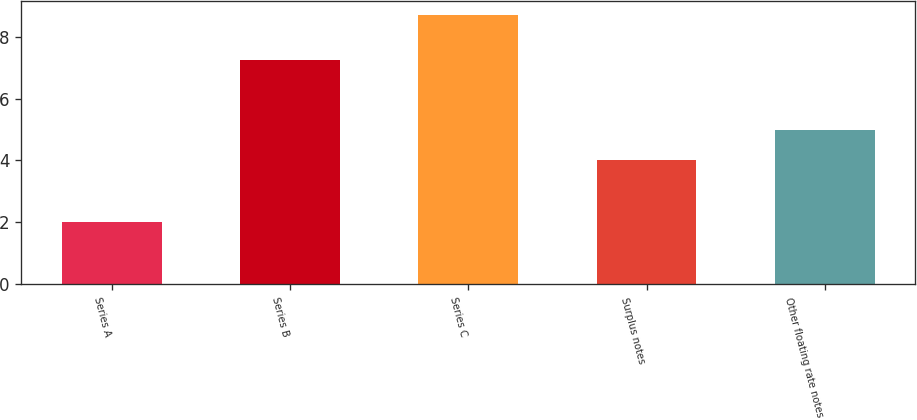<chart> <loc_0><loc_0><loc_500><loc_500><bar_chart><fcel>Series A<fcel>Series B<fcel>Series C<fcel>Surplus notes<fcel>Other floating rate notes<nl><fcel>2<fcel>7.25<fcel>8.7<fcel>4<fcel>5<nl></chart> 